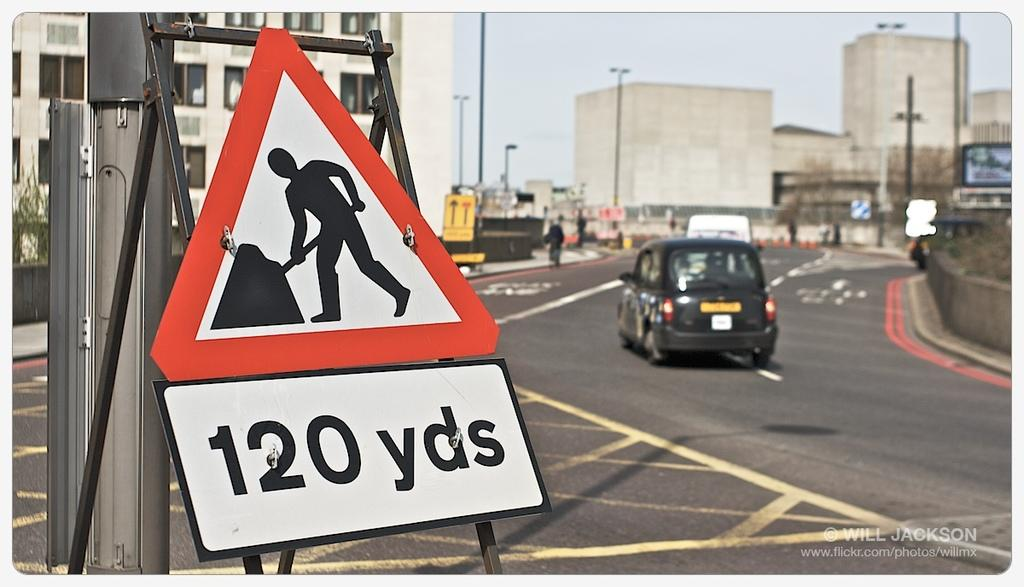<image>
Offer a succinct explanation of the picture presented. a sign that has the number 120 on it 